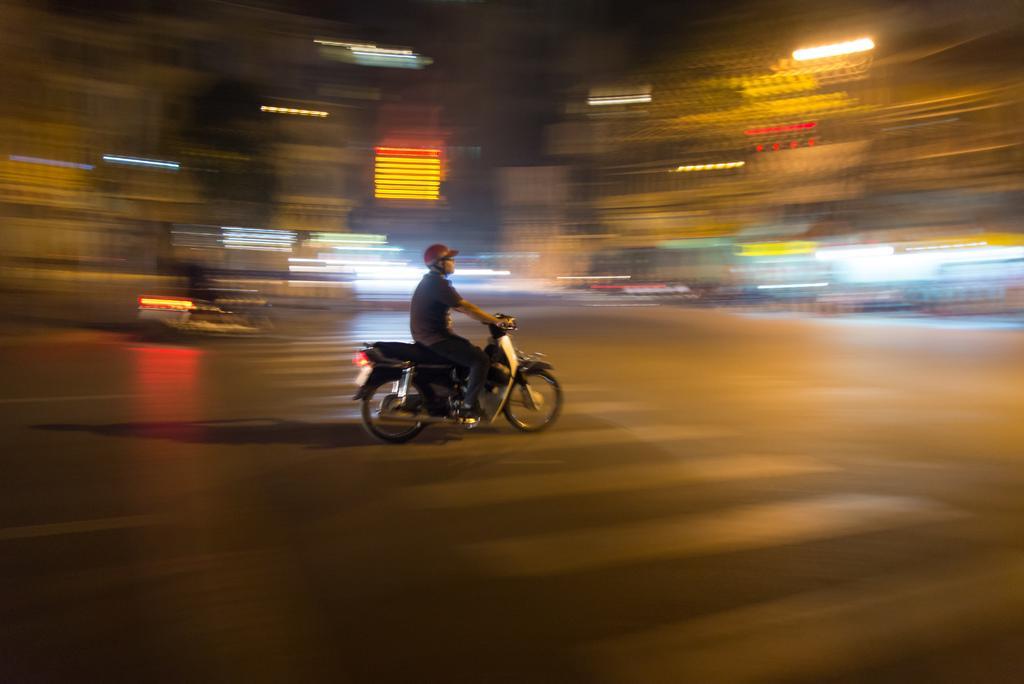Please provide a concise description of this image. Person riding bike wearing helmet,this is zebra crossing and the road in the back this are lights. 